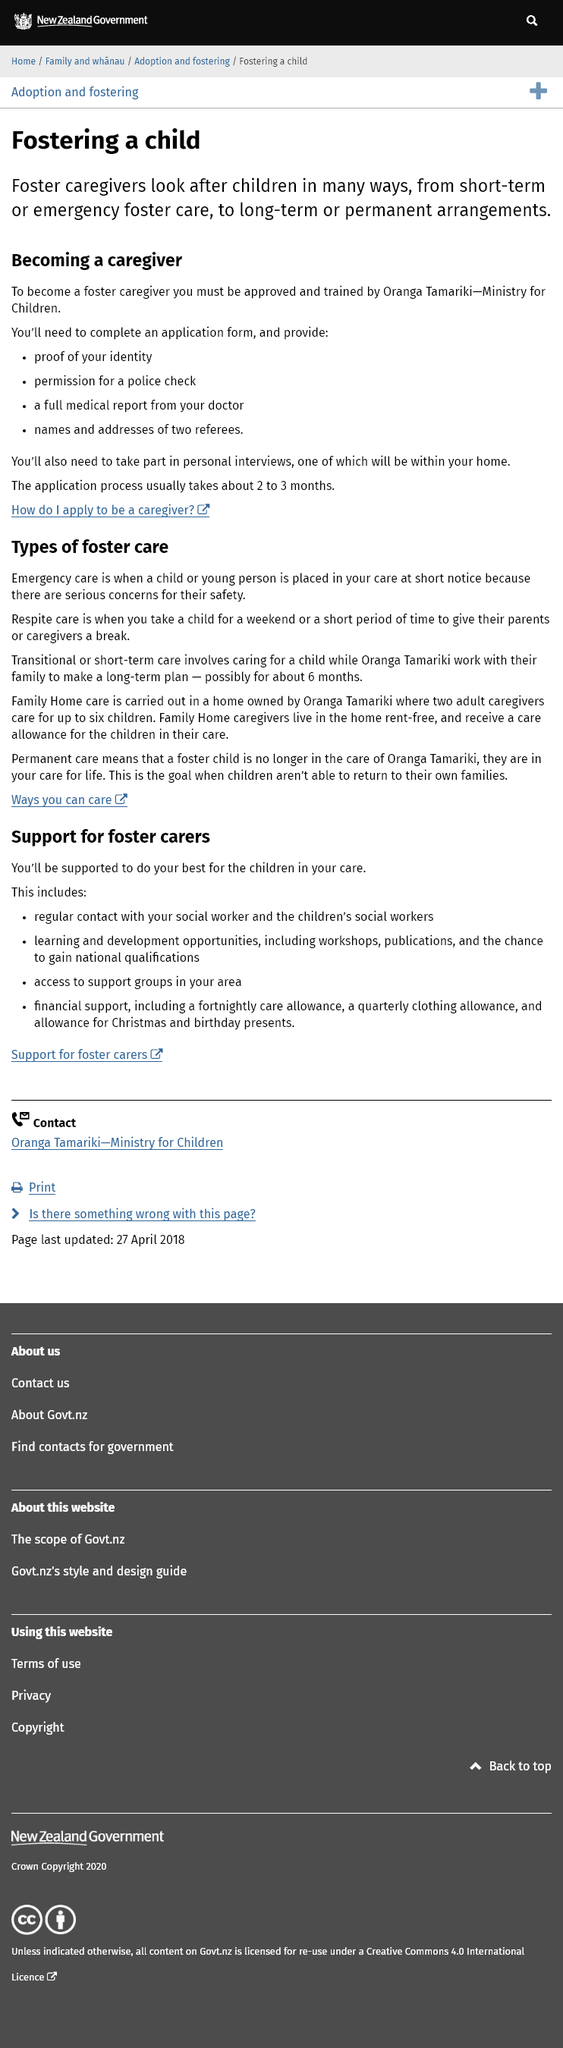Give some essential details in this illustration. To become a foster caregiver, one must be approved and trained by Oranga Tamariki-Ministry for Children and complete an application form, providing proof of identity, permission for a police check, a full medical report from a doctor, and names and addresses of two referees. Interviews will also be required, one of which must be held in the applicant's home. The application process for fostering typically takes approximately two to three months, beginning to end. Foster caregivers perform various duties to provide care and support to children in need, including short term or emergency foster care, and long term or permanent arrangements. 